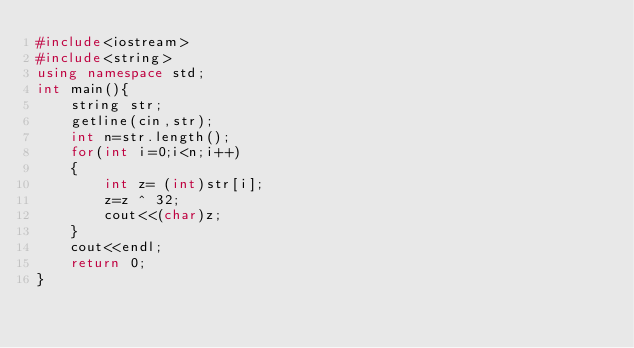<code> <loc_0><loc_0><loc_500><loc_500><_C++_>#include<iostream>
#include<string>
using namespace std;
int main(){
	string str;
	getline(cin,str);
	int n=str.length();
	for(int i=0;i<n;i++)
	{
		int z= (int)str[i];
		z=z ^ 32;
		cout<<(char)z;
	}
	cout<<endl;
	return 0;
}</code> 